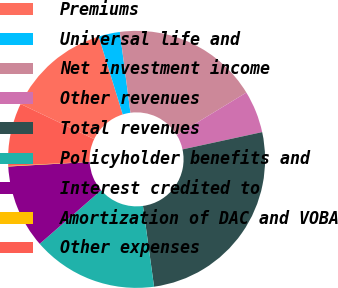<chart> <loc_0><loc_0><loc_500><loc_500><pie_chart><fcel>Premiums<fcel>Universal life and<fcel>Net investment income<fcel>Other revenues<fcel>Total revenues<fcel>Policyholder benefits and<fcel>Interest credited to<fcel>Amortization of DAC and VOBA<fcel>Other expenses<nl><fcel>13.15%<fcel>2.68%<fcel>18.38%<fcel>5.3%<fcel>26.23%<fcel>15.76%<fcel>10.53%<fcel>0.07%<fcel>7.91%<nl></chart> 